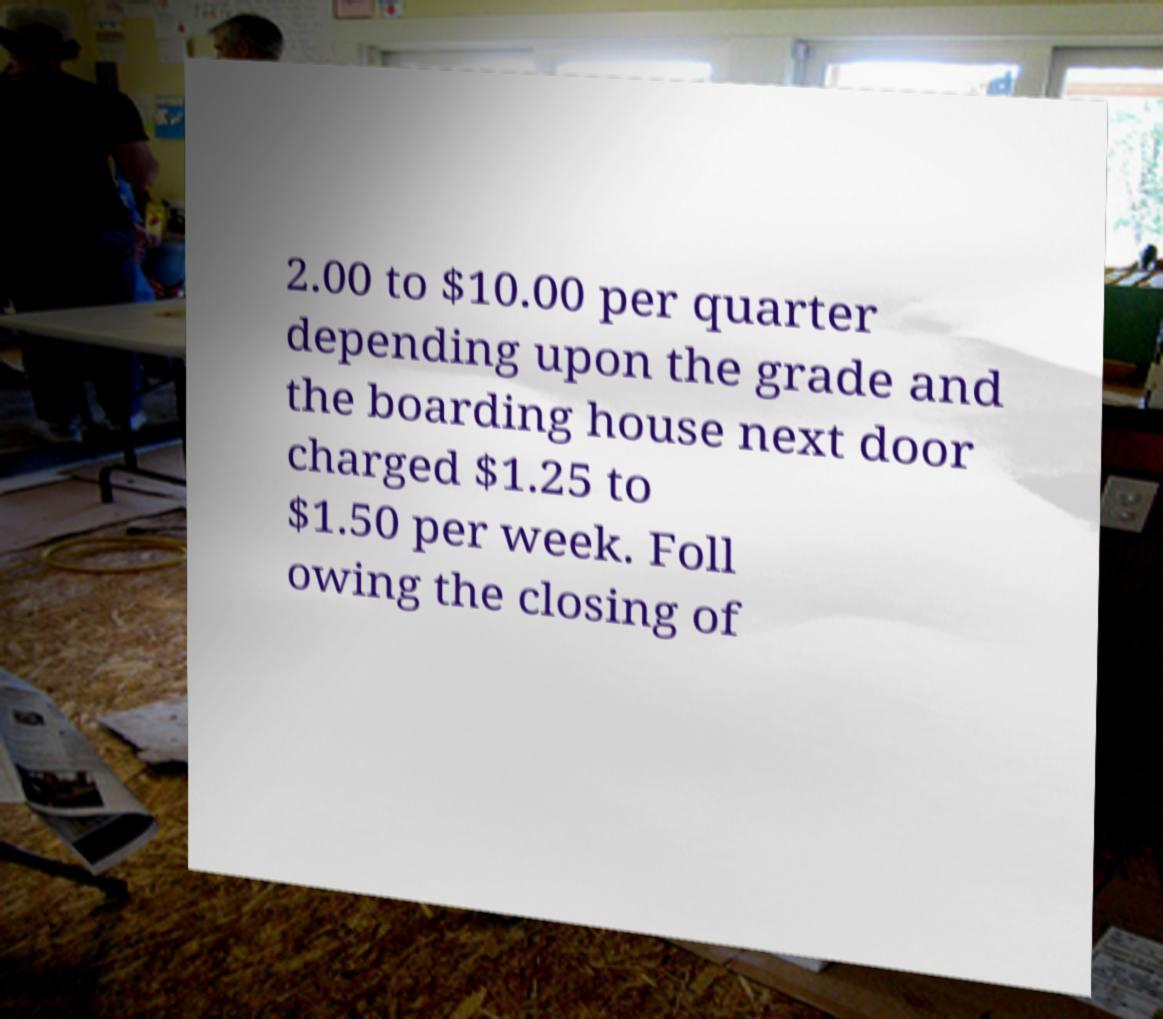Can you read and provide the text displayed in the image?This photo seems to have some interesting text. Can you extract and type it out for me? 2.00 to $10.00 per quarter depending upon the grade and the boarding house next door charged $1.25 to $1.50 per week. Foll owing the closing of 